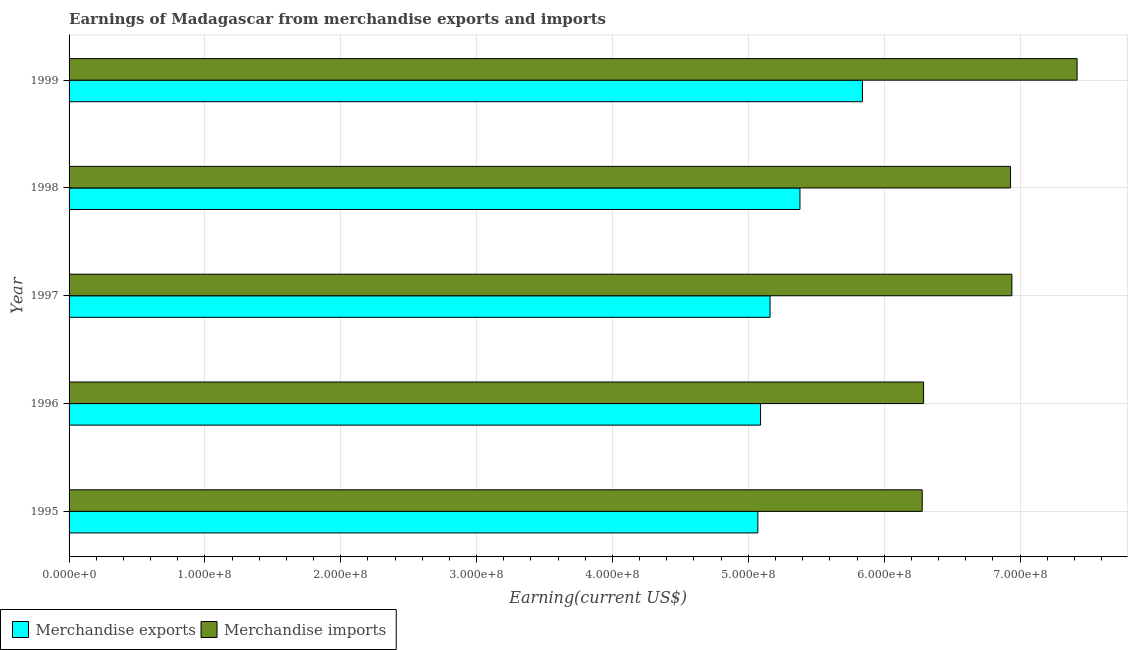How many different coloured bars are there?
Keep it short and to the point. 2. How many groups of bars are there?
Keep it short and to the point. 5. Are the number of bars on each tick of the Y-axis equal?
Your answer should be very brief. Yes. How many bars are there on the 5th tick from the top?
Your response must be concise. 2. How many bars are there on the 2nd tick from the bottom?
Ensure brevity in your answer.  2. What is the label of the 1st group of bars from the top?
Your response must be concise. 1999. In how many cases, is the number of bars for a given year not equal to the number of legend labels?
Offer a very short reply. 0. What is the earnings from merchandise exports in 1995?
Provide a short and direct response. 5.07e+08. Across all years, what is the maximum earnings from merchandise exports?
Offer a terse response. 5.84e+08. Across all years, what is the minimum earnings from merchandise exports?
Offer a very short reply. 5.07e+08. In which year was the earnings from merchandise imports maximum?
Your answer should be compact. 1999. In which year was the earnings from merchandise imports minimum?
Provide a short and direct response. 1995. What is the total earnings from merchandise imports in the graph?
Provide a succinct answer. 3.39e+09. What is the difference between the earnings from merchandise exports in 1996 and that in 1999?
Make the answer very short. -7.50e+07. What is the difference between the earnings from merchandise exports in 1999 and the earnings from merchandise imports in 1998?
Your response must be concise. -1.09e+08. What is the average earnings from merchandise exports per year?
Provide a short and direct response. 5.31e+08. In the year 1997, what is the difference between the earnings from merchandise exports and earnings from merchandise imports?
Give a very brief answer. -1.78e+08. In how many years, is the earnings from merchandise exports greater than 320000000 US$?
Offer a very short reply. 5. Is the earnings from merchandise imports in 1997 less than that in 1999?
Offer a very short reply. Yes. What is the difference between the highest and the second highest earnings from merchandise exports?
Your answer should be compact. 4.60e+07. What is the difference between the highest and the lowest earnings from merchandise exports?
Give a very brief answer. 7.70e+07. In how many years, is the earnings from merchandise exports greater than the average earnings from merchandise exports taken over all years?
Provide a short and direct response. 2. Are the values on the major ticks of X-axis written in scientific E-notation?
Provide a succinct answer. Yes. Does the graph contain any zero values?
Your response must be concise. No. Where does the legend appear in the graph?
Keep it short and to the point. Bottom left. How are the legend labels stacked?
Your response must be concise. Horizontal. What is the title of the graph?
Make the answer very short. Earnings of Madagascar from merchandise exports and imports. What is the label or title of the X-axis?
Offer a terse response. Earning(current US$). What is the label or title of the Y-axis?
Provide a succinct answer. Year. What is the Earning(current US$) in Merchandise exports in 1995?
Offer a very short reply. 5.07e+08. What is the Earning(current US$) of Merchandise imports in 1995?
Ensure brevity in your answer.  6.28e+08. What is the Earning(current US$) in Merchandise exports in 1996?
Your answer should be compact. 5.09e+08. What is the Earning(current US$) in Merchandise imports in 1996?
Offer a very short reply. 6.29e+08. What is the Earning(current US$) in Merchandise exports in 1997?
Give a very brief answer. 5.16e+08. What is the Earning(current US$) of Merchandise imports in 1997?
Ensure brevity in your answer.  6.94e+08. What is the Earning(current US$) of Merchandise exports in 1998?
Your answer should be compact. 5.38e+08. What is the Earning(current US$) in Merchandise imports in 1998?
Provide a succinct answer. 6.93e+08. What is the Earning(current US$) in Merchandise exports in 1999?
Offer a very short reply. 5.84e+08. What is the Earning(current US$) in Merchandise imports in 1999?
Your answer should be very brief. 7.42e+08. Across all years, what is the maximum Earning(current US$) in Merchandise exports?
Make the answer very short. 5.84e+08. Across all years, what is the maximum Earning(current US$) of Merchandise imports?
Keep it short and to the point. 7.42e+08. Across all years, what is the minimum Earning(current US$) of Merchandise exports?
Keep it short and to the point. 5.07e+08. Across all years, what is the minimum Earning(current US$) in Merchandise imports?
Ensure brevity in your answer.  6.28e+08. What is the total Earning(current US$) in Merchandise exports in the graph?
Make the answer very short. 2.65e+09. What is the total Earning(current US$) of Merchandise imports in the graph?
Provide a succinct answer. 3.39e+09. What is the difference between the Earning(current US$) of Merchandise imports in 1995 and that in 1996?
Your answer should be very brief. -1.00e+06. What is the difference between the Earning(current US$) of Merchandise exports in 1995 and that in 1997?
Provide a succinct answer. -9.00e+06. What is the difference between the Earning(current US$) of Merchandise imports in 1995 and that in 1997?
Make the answer very short. -6.60e+07. What is the difference between the Earning(current US$) of Merchandise exports in 1995 and that in 1998?
Provide a succinct answer. -3.10e+07. What is the difference between the Earning(current US$) of Merchandise imports in 1995 and that in 1998?
Your response must be concise. -6.50e+07. What is the difference between the Earning(current US$) in Merchandise exports in 1995 and that in 1999?
Your answer should be compact. -7.70e+07. What is the difference between the Earning(current US$) of Merchandise imports in 1995 and that in 1999?
Ensure brevity in your answer.  -1.14e+08. What is the difference between the Earning(current US$) in Merchandise exports in 1996 and that in 1997?
Make the answer very short. -7.00e+06. What is the difference between the Earning(current US$) of Merchandise imports in 1996 and that in 1997?
Give a very brief answer. -6.50e+07. What is the difference between the Earning(current US$) of Merchandise exports in 1996 and that in 1998?
Offer a terse response. -2.90e+07. What is the difference between the Earning(current US$) in Merchandise imports in 1996 and that in 1998?
Provide a succinct answer. -6.40e+07. What is the difference between the Earning(current US$) in Merchandise exports in 1996 and that in 1999?
Give a very brief answer. -7.50e+07. What is the difference between the Earning(current US$) in Merchandise imports in 1996 and that in 1999?
Offer a very short reply. -1.13e+08. What is the difference between the Earning(current US$) of Merchandise exports in 1997 and that in 1998?
Make the answer very short. -2.20e+07. What is the difference between the Earning(current US$) of Merchandise imports in 1997 and that in 1998?
Offer a very short reply. 1.00e+06. What is the difference between the Earning(current US$) of Merchandise exports in 1997 and that in 1999?
Give a very brief answer. -6.80e+07. What is the difference between the Earning(current US$) in Merchandise imports in 1997 and that in 1999?
Offer a very short reply. -4.80e+07. What is the difference between the Earning(current US$) in Merchandise exports in 1998 and that in 1999?
Keep it short and to the point. -4.60e+07. What is the difference between the Earning(current US$) of Merchandise imports in 1998 and that in 1999?
Keep it short and to the point. -4.90e+07. What is the difference between the Earning(current US$) in Merchandise exports in 1995 and the Earning(current US$) in Merchandise imports in 1996?
Offer a very short reply. -1.22e+08. What is the difference between the Earning(current US$) in Merchandise exports in 1995 and the Earning(current US$) in Merchandise imports in 1997?
Offer a very short reply. -1.87e+08. What is the difference between the Earning(current US$) in Merchandise exports in 1995 and the Earning(current US$) in Merchandise imports in 1998?
Offer a terse response. -1.86e+08. What is the difference between the Earning(current US$) in Merchandise exports in 1995 and the Earning(current US$) in Merchandise imports in 1999?
Keep it short and to the point. -2.35e+08. What is the difference between the Earning(current US$) in Merchandise exports in 1996 and the Earning(current US$) in Merchandise imports in 1997?
Offer a terse response. -1.85e+08. What is the difference between the Earning(current US$) in Merchandise exports in 1996 and the Earning(current US$) in Merchandise imports in 1998?
Offer a very short reply. -1.84e+08. What is the difference between the Earning(current US$) of Merchandise exports in 1996 and the Earning(current US$) of Merchandise imports in 1999?
Your response must be concise. -2.33e+08. What is the difference between the Earning(current US$) of Merchandise exports in 1997 and the Earning(current US$) of Merchandise imports in 1998?
Provide a succinct answer. -1.77e+08. What is the difference between the Earning(current US$) in Merchandise exports in 1997 and the Earning(current US$) in Merchandise imports in 1999?
Provide a short and direct response. -2.26e+08. What is the difference between the Earning(current US$) in Merchandise exports in 1998 and the Earning(current US$) in Merchandise imports in 1999?
Provide a succinct answer. -2.04e+08. What is the average Earning(current US$) of Merchandise exports per year?
Offer a terse response. 5.31e+08. What is the average Earning(current US$) of Merchandise imports per year?
Provide a succinct answer. 6.77e+08. In the year 1995, what is the difference between the Earning(current US$) of Merchandise exports and Earning(current US$) of Merchandise imports?
Your response must be concise. -1.21e+08. In the year 1996, what is the difference between the Earning(current US$) in Merchandise exports and Earning(current US$) in Merchandise imports?
Provide a short and direct response. -1.20e+08. In the year 1997, what is the difference between the Earning(current US$) in Merchandise exports and Earning(current US$) in Merchandise imports?
Keep it short and to the point. -1.78e+08. In the year 1998, what is the difference between the Earning(current US$) of Merchandise exports and Earning(current US$) of Merchandise imports?
Your response must be concise. -1.55e+08. In the year 1999, what is the difference between the Earning(current US$) of Merchandise exports and Earning(current US$) of Merchandise imports?
Make the answer very short. -1.58e+08. What is the ratio of the Earning(current US$) in Merchandise exports in 1995 to that in 1996?
Your response must be concise. 1. What is the ratio of the Earning(current US$) in Merchandise exports in 1995 to that in 1997?
Your answer should be compact. 0.98. What is the ratio of the Earning(current US$) of Merchandise imports in 1995 to that in 1997?
Keep it short and to the point. 0.9. What is the ratio of the Earning(current US$) in Merchandise exports in 1995 to that in 1998?
Offer a very short reply. 0.94. What is the ratio of the Earning(current US$) of Merchandise imports in 1995 to that in 1998?
Ensure brevity in your answer.  0.91. What is the ratio of the Earning(current US$) of Merchandise exports in 1995 to that in 1999?
Keep it short and to the point. 0.87. What is the ratio of the Earning(current US$) of Merchandise imports in 1995 to that in 1999?
Offer a very short reply. 0.85. What is the ratio of the Earning(current US$) of Merchandise exports in 1996 to that in 1997?
Offer a very short reply. 0.99. What is the ratio of the Earning(current US$) in Merchandise imports in 1996 to that in 1997?
Your answer should be compact. 0.91. What is the ratio of the Earning(current US$) in Merchandise exports in 1996 to that in 1998?
Your answer should be compact. 0.95. What is the ratio of the Earning(current US$) in Merchandise imports in 1996 to that in 1998?
Ensure brevity in your answer.  0.91. What is the ratio of the Earning(current US$) in Merchandise exports in 1996 to that in 1999?
Your answer should be compact. 0.87. What is the ratio of the Earning(current US$) of Merchandise imports in 1996 to that in 1999?
Offer a terse response. 0.85. What is the ratio of the Earning(current US$) of Merchandise exports in 1997 to that in 1998?
Offer a terse response. 0.96. What is the ratio of the Earning(current US$) in Merchandise imports in 1997 to that in 1998?
Provide a succinct answer. 1. What is the ratio of the Earning(current US$) in Merchandise exports in 1997 to that in 1999?
Ensure brevity in your answer.  0.88. What is the ratio of the Earning(current US$) in Merchandise imports in 1997 to that in 1999?
Keep it short and to the point. 0.94. What is the ratio of the Earning(current US$) of Merchandise exports in 1998 to that in 1999?
Give a very brief answer. 0.92. What is the ratio of the Earning(current US$) in Merchandise imports in 1998 to that in 1999?
Your response must be concise. 0.93. What is the difference between the highest and the second highest Earning(current US$) of Merchandise exports?
Provide a succinct answer. 4.60e+07. What is the difference between the highest and the second highest Earning(current US$) of Merchandise imports?
Your response must be concise. 4.80e+07. What is the difference between the highest and the lowest Earning(current US$) in Merchandise exports?
Provide a short and direct response. 7.70e+07. What is the difference between the highest and the lowest Earning(current US$) in Merchandise imports?
Your answer should be very brief. 1.14e+08. 